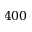Convert formula to latex. <formula><loc_0><loc_0><loc_500><loc_500>4 0 0</formula> 